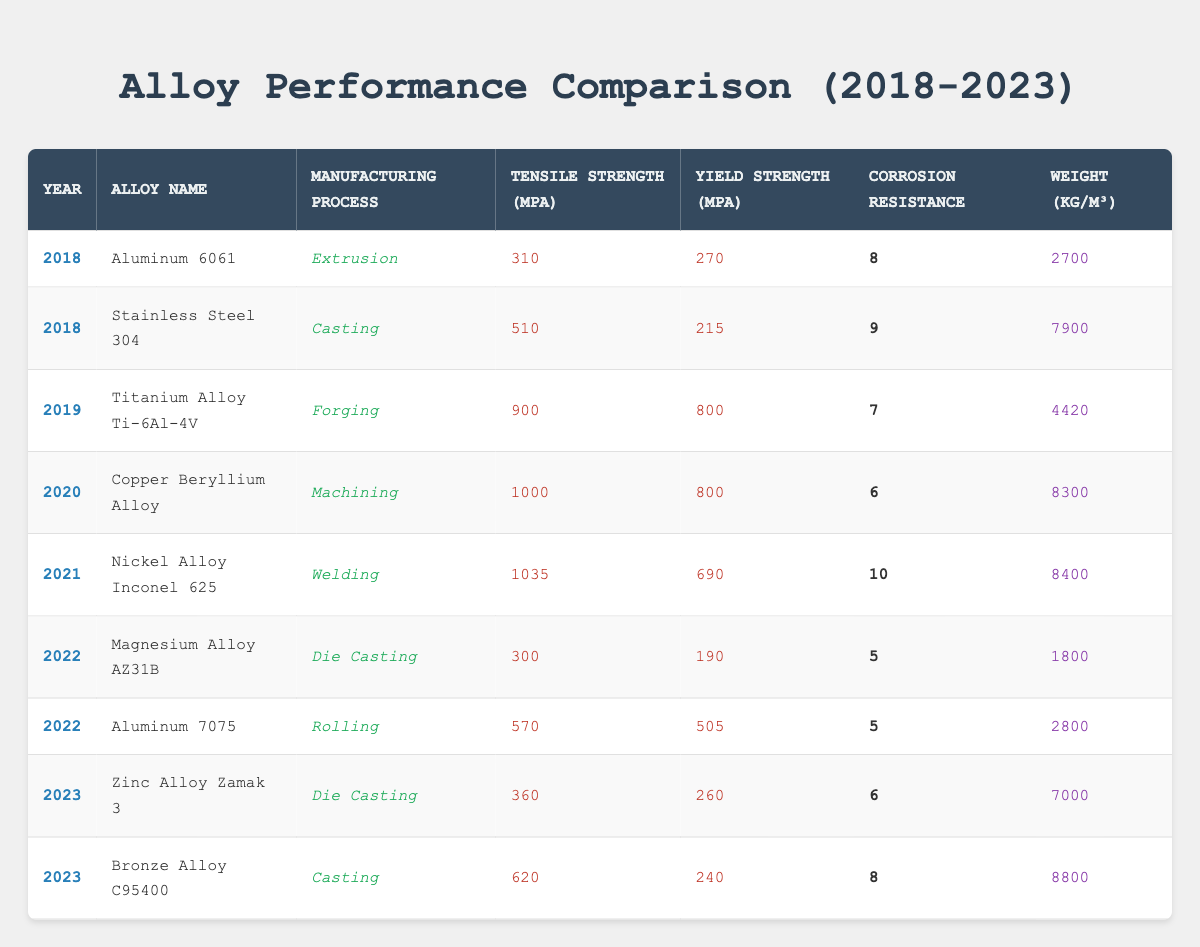What is the tensile strength of Aluminum 6061? The table lists the tensile strength of Aluminum 6061 under the year 2018 as 310 MPa.
Answer: 310 MPa What is the yield strength of Nickel Alloy Inconel 625? The table shows the yield strength for Nickel Alloy Inconel 625 in 2021, which is recorded as 690 MPa.
Answer: 690 MPa Which alloy has the highest corrosion resistance rating? Looking at the corrosion resistance ratings, Nickel Alloy Inconel 625 has the highest rating of 10.
Answer: 10 What is the average tensile strength of alloys manufactured in 2022? The tensile strengths of alloys in 2022 are 300 MPa for Magnesium Alloy AZ31B and 570 MPa for Aluminum 7075. The average is (300 + 570) / 2 = 435 MPa.
Answer: 435 MPa Is the corrosion resistance rating of Copper Beryllium Alloy higher than that of Magnesium Alloy AZ31B? Copper Beryllium Alloy has a corrosion resistance rating of 6, while Magnesium Alloy AZ31B has a rating of 5. Therefore, the statement is true.
Answer: Yes What is the relationship between tensile strength and manufacturing process for the years available? Analyzing the data, we can see that forging (Titanium Alloy Ti-6Al-4V in 2019) and machining (Copper Beryllium Alloy in 2020) show high tensile strength values. This could suggest that these processes might lead to stronger alloys, but a detailed study is required to confirm this.
Answer: Further analysis needed What is the difference in yield strength between Titanium Alloy Ti-6Al-4V and Aluminum 7075? The yield strength of Titanium Alloy Ti-6Al-4V is 800 MPa, and for Aluminum 7075 it is 505 MPa. The difference is 800 - 505 = 295 MPa.
Answer: 295 MPa Which alloy had the lowest tensile strength in 2022? The table indicates that Magnesium Alloy AZ31B had the lowest tensile strength in 2022 at 300 MPa.
Answer: 300 MPa In which year did the performance characteristics of Stainless Steel 304 get recorded? The table lists the performance characteristics of Stainless Steel 304 in the year 2018.
Answer: 2018 How does the weight of Zinc Alloy Zamak 3 compare to Aluminum 6061? The weight of Zinc Alloy Zamak 3 recorded in 2023 is 7000 kg/m³, while Aluminum 6061 in 2018 weighs 2700 kg/m³. Zamak 3 is heavier by 7000 - 2700 = 4300 kg/m³.
Answer: 4300 kg/m³ heavier What can we infer about the increasing yield strengths in the alloys from 2018 to 2021? Yield strengths increased from 270 MPa (Aluminum 6061 in 2018) to 690 MPa (Nickel Alloy Inconel 625 in 2021), indicating a trend of improving material performance. This suggests advancements in alloy formulations or manufacturing processes over these years.
Answer: Trend of improvement evident 